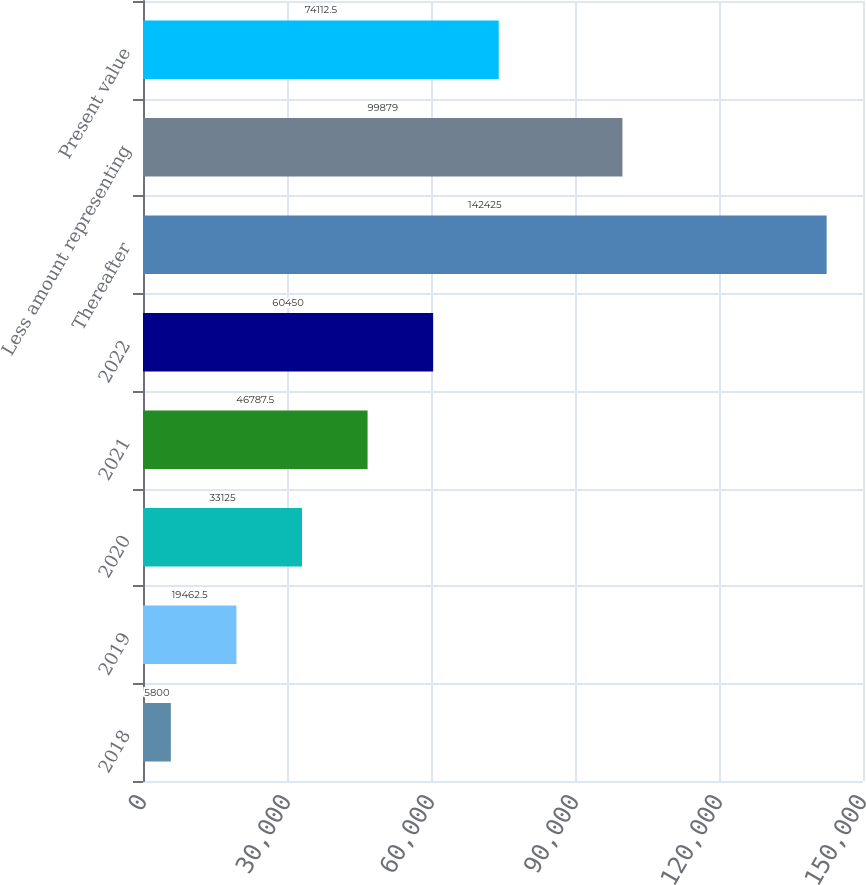Convert chart to OTSL. <chart><loc_0><loc_0><loc_500><loc_500><bar_chart><fcel>2018<fcel>2019<fcel>2020<fcel>2021<fcel>2022<fcel>Thereafter<fcel>Less amount representing<fcel>Present value<nl><fcel>5800<fcel>19462.5<fcel>33125<fcel>46787.5<fcel>60450<fcel>142425<fcel>99879<fcel>74112.5<nl></chart> 